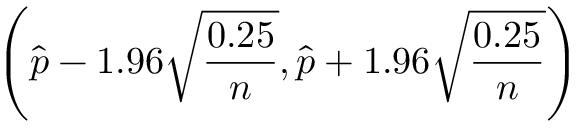Convert formula to latex. <formula><loc_0><loc_0><loc_500><loc_500>\left ( { \widehat { p } } - 1 . 9 6 { \sqrt { \frac { 0 . 2 5 } { n } } } , { \widehat { p } } + 1 . 9 6 { \sqrt { \frac { 0 . 2 5 } { n } } } \right )</formula> 